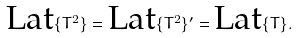<formula> <loc_0><loc_0><loc_500><loc_500>\text {Lat} \{ T ^ { 2 } \} = \text {Lat} \{ T ^ { 2 } \} ^ { \prime } = \text {Lat} \{ T \} .</formula> 